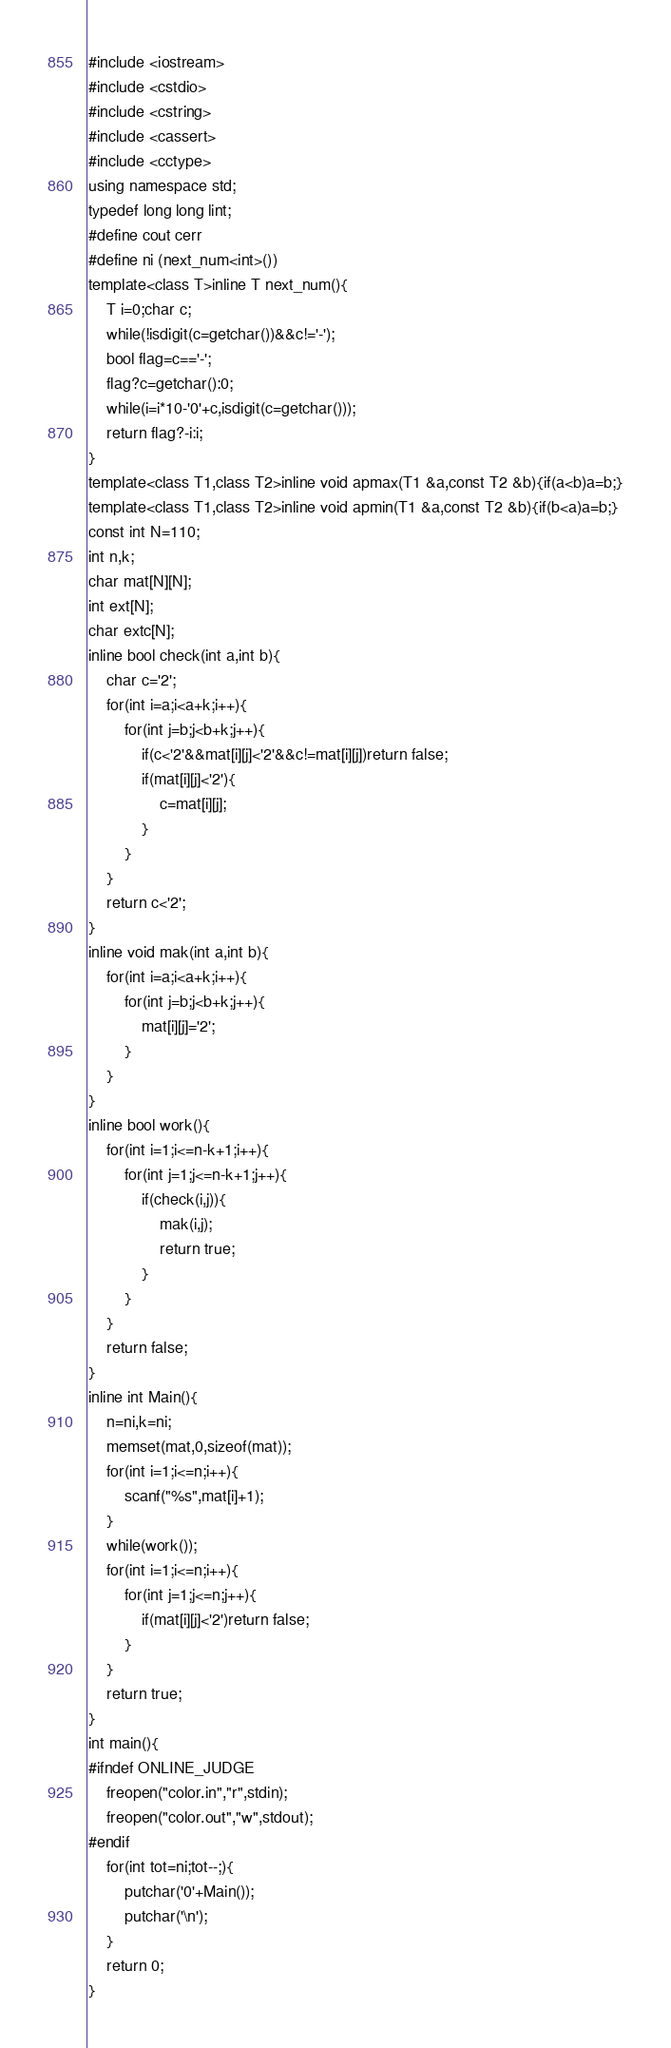<code> <loc_0><loc_0><loc_500><loc_500><_C++_>#include <iostream>
#include <cstdio>
#include <cstring>
#include <cassert>
#include <cctype>
using namespace std;
typedef long long lint;
#define cout cerr
#define ni (next_num<int>())
template<class T>inline T next_num(){
	T i=0;char c;
	while(!isdigit(c=getchar())&&c!='-');
	bool flag=c=='-';
	flag?c=getchar():0;
	while(i=i*10-'0'+c,isdigit(c=getchar()));
	return flag?-i:i;
}
template<class T1,class T2>inline void apmax(T1 &a,const T2 &b){if(a<b)a=b;}
template<class T1,class T2>inline void apmin(T1 &a,const T2 &b){if(b<a)a=b;}
const int N=110;
int n,k;
char mat[N][N];
int ext[N];
char extc[N];
inline bool check(int a,int b){
	char c='2';
	for(int i=a;i<a+k;i++){
		for(int j=b;j<b+k;j++){
			if(c<'2'&&mat[i][j]<'2'&&c!=mat[i][j])return false;
			if(mat[i][j]<'2'){
				c=mat[i][j];
			}
		}
	}
	return c<'2';
}
inline void mak(int a,int b){
	for(int i=a;i<a+k;i++){
		for(int j=b;j<b+k;j++){
			mat[i][j]='2';
		}
	}
}
inline bool work(){
	for(int i=1;i<=n-k+1;i++){
		for(int j=1;j<=n-k+1;j++){
			if(check(i,j)){
				mak(i,j);
				return true;
			}
		}
	}
	return false;
}
inline int Main(){
	n=ni,k=ni;
	memset(mat,0,sizeof(mat));
	for(int i=1;i<=n;i++){
		scanf("%s",mat[i]+1);
	}
	while(work());
	for(int i=1;i<=n;i++){
		for(int j=1;j<=n;j++){
			if(mat[i][j]<'2')return false;
		}
	}
	return true;
}
int main(){
#ifndef ONLINE_JUDGE
	freopen("color.in","r",stdin);
	freopen("color.out","w",stdout);
#endif
	for(int tot=ni;tot--;){
		putchar('0'+Main());
		putchar('\n');
	}
	return 0;
}
</code> 